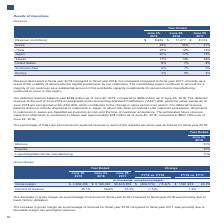According to Lam Research Corporation's financial document, What is the deferred revenue at the end of June 2019 recognised under? Accounting Standard Codification (“ASC”) 606. The document states: "venue at the end of June 2019 is recognized under Accounting Standard Codification (“ASC”) 606, while the same values as of June 2018 are recognized u..." Also, What is the percentage of Korea revenue in the total revenue on June 30, 2019? According to the financial document, 23%. The relevant text states: "Korea 23% 35% 31%..." Also, What is the percentage of China revenue in the total revenue on June 24, 2018? According to the financial document, 16%. The relevant text states: "China 22% 16% 13%..." Also, can you calculate: What is the percentage change in the total revenue from 2018 to 2019? To answer this question, I need to perform calculations using the financial data. The calculation is: (9,654-11,077)/11,077, which equals -12.85 (percentage). This is based on the information: "Revenue (in millions) $ 9,654 $ 11,077 $ 8,014 Revenue (in millions) $ 9,654 $ 11,077 $ 8,014..." The key data points involved are: 11,077, 9,654. Also, can you calculate: What is the percentage change in the deferred revenue balance from 2018 to 2019? To answer this question, I need to perform calculations using the financial data. The calculation is: (449-994)/994, which equals -54.83 (percentage). This is based on the information: "Our deferred revenue balance was $449 million as of June 30, 2019, compared to $994 million as of June 24, 2018. The deferred revenue at as $449 million as of June 30, 2019, compared to $994 million a..." The key data points involved are: 449, 994. Also, can you calculate: What is the percentage change in the anticipated future revenue value from shipments to customers in Japan from 2018 to 2019? To answer this question, I need to perform calculations using the financial data. The calculation is: (78-607)/607, which equals -87.15 (percentage). This is based on the information: "hipments to customers in Japan was approximately $78 million as of June 30, 2019, compared to $607 million as of June 24, 2018. ely $78 million as of June 30, 2019, compared to $607 million as of June..." The key data points involved are: 607, 78. 